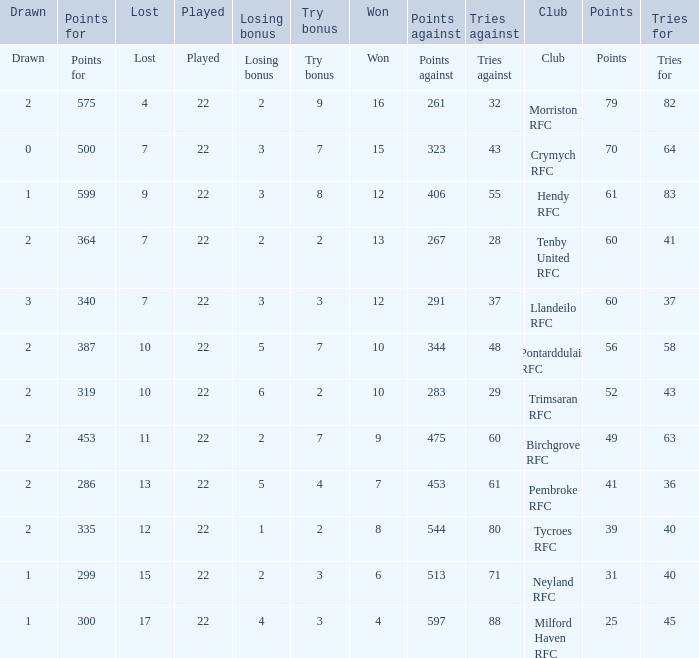What's the club with losing bonus being 1 Tycroes RFC. 